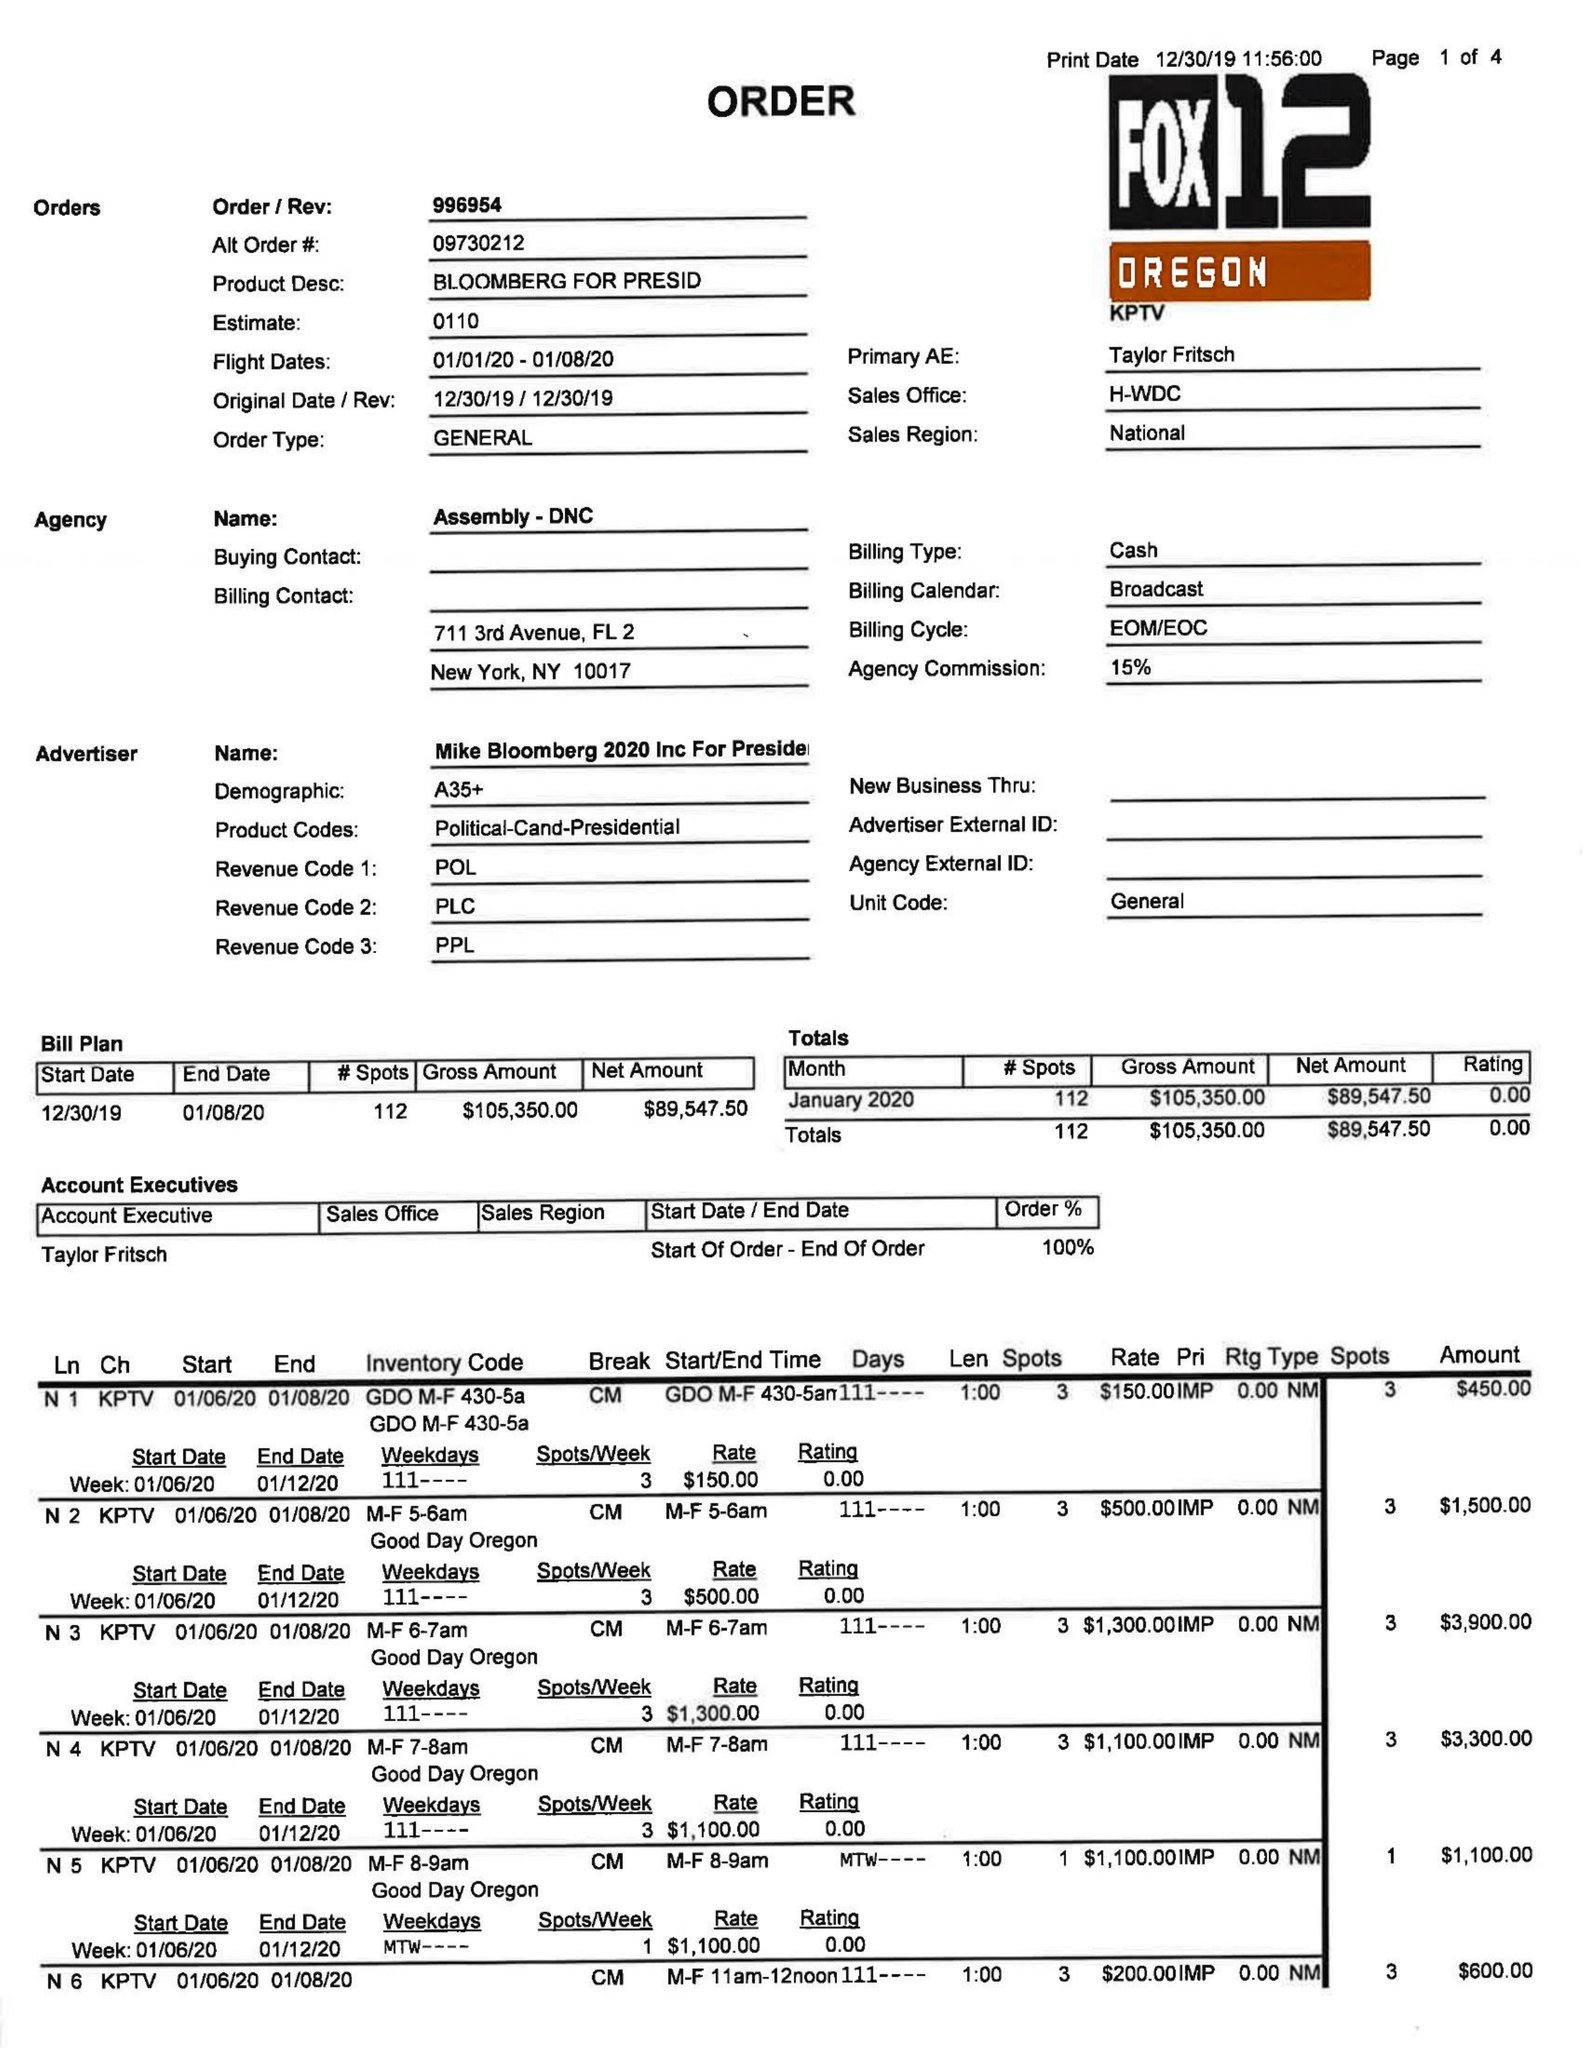What is the value for the flight_to?
Answer the question using a single word or phrase. 01/08/20 